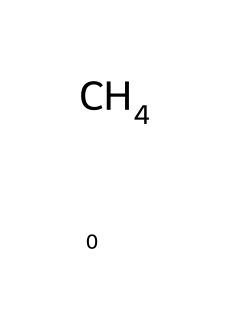What is the chemical name of this compound? The structure shows a single carbon atom, which corresponds to methane (the simplest alkane).
Answer: methane How many hydrogen atoms are present in the molecule? The structure indicates one carbon atom bonded to four hydrogen atoms, as per methane's formula (CH4).
Answer: four What type of bond exists between the carbon and hydrogen atoms? The structure depicts single bonds between the carbon atom and each hydrogen atom, characteristic of saturated hydrocarbons like methane.
Answer: single bond Is this compound a greenhouse gas? Methane is recognized as a potent greenhouse gas due to its ability to trap heat in the atmosphere effectively.
Answer: yes What is the significance of methane in the energy sector? Methane is a major component of natural gas, widely used as a fuel source for electricity generation and heating.
Answer: fuel source What is the primary application of methane in industry? Methane is primarily used for energy production, making it essential for power generation and heating applications.
Answer: energy production Why is methane considered more efficient than other fossil fuels? Methane has a higher energy content per unit of carbon dioxide emitted upon combustion compared to coal or oil.
Answer: efficient 